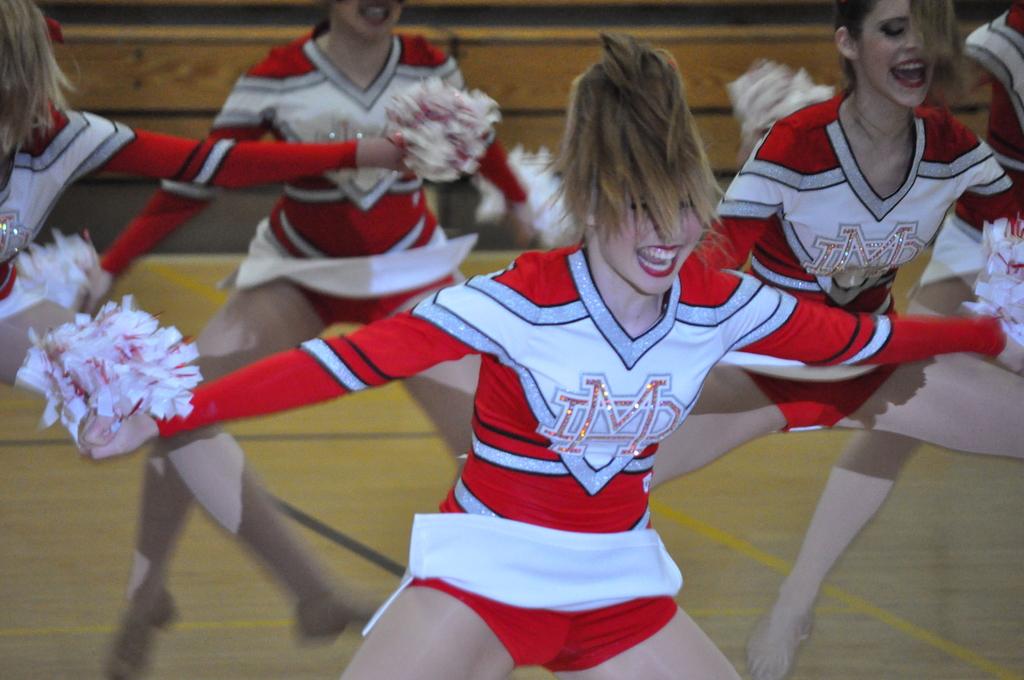What letters are on her shirt?
Keep it short and to the point. Imd. 